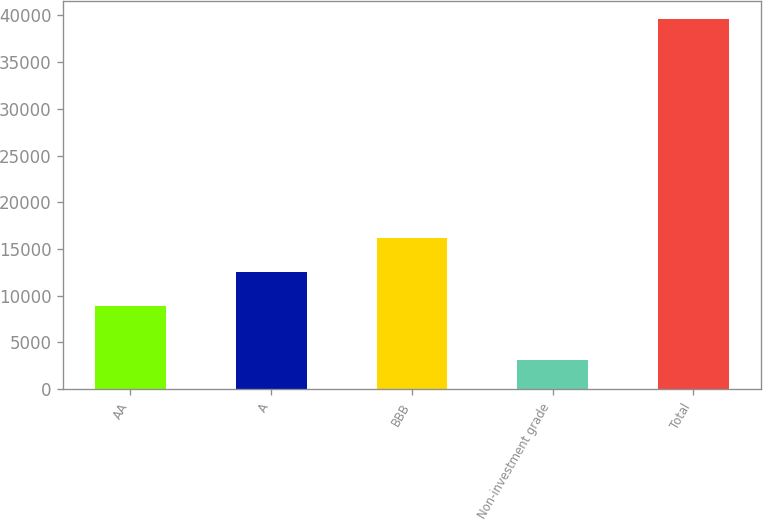Convert chart to OTSL. <chart><loc_0><loc_0><loc_500><loc_500><bar_chart><fcel>AA<fcel>A<fcel>BBB<fcel>Non-investment grade<fcel>Total<nl><fcel>8919<fcel>12559.6<fcel>16200.2<fcel>3166<fcel>39572<nl></chart> 